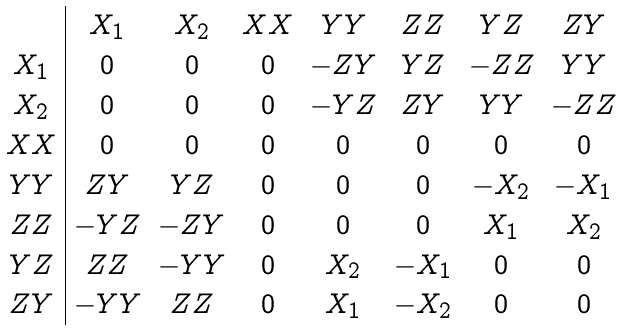<formula> <loc_0><loc_0><loc_500><loc_500>\begin{array} { c | c c c c c c c } & X _ { 1 } & X _ { 2 } & X X & Y Y & Z Z & Y Z & Z Y \\ X _ { 1 } & 0 & 0 & 0 & - Z Y & Y Z & - Z Z & Y Y \\ X _ { 2 } & 0 & 0 & 0 & - Y Z & Z Y & Y Y & - Z Z \\ X X & 0 & 0 & 0 & 0 & 0 & 0 & 0 \\ Y Y & Z Y & Y Z & 0 & 0 & 0 & - X _ { 2 } & - X _ { 1 } \\ Z Z & - Y Z & - Z Y & 0 & 0 & 0 & X _ { 1 } & X _ { 2 } \\ Y Z & Z Z & - Y Y & 0 & X _ { 2 } & - X _ { 1 } & 0 & 0 \\ Z Y & - Y Y & Z Z & 0 & X _ { 1 } & - X _ { 2 } & 0 & 0 \\ \end{array}</formula> 